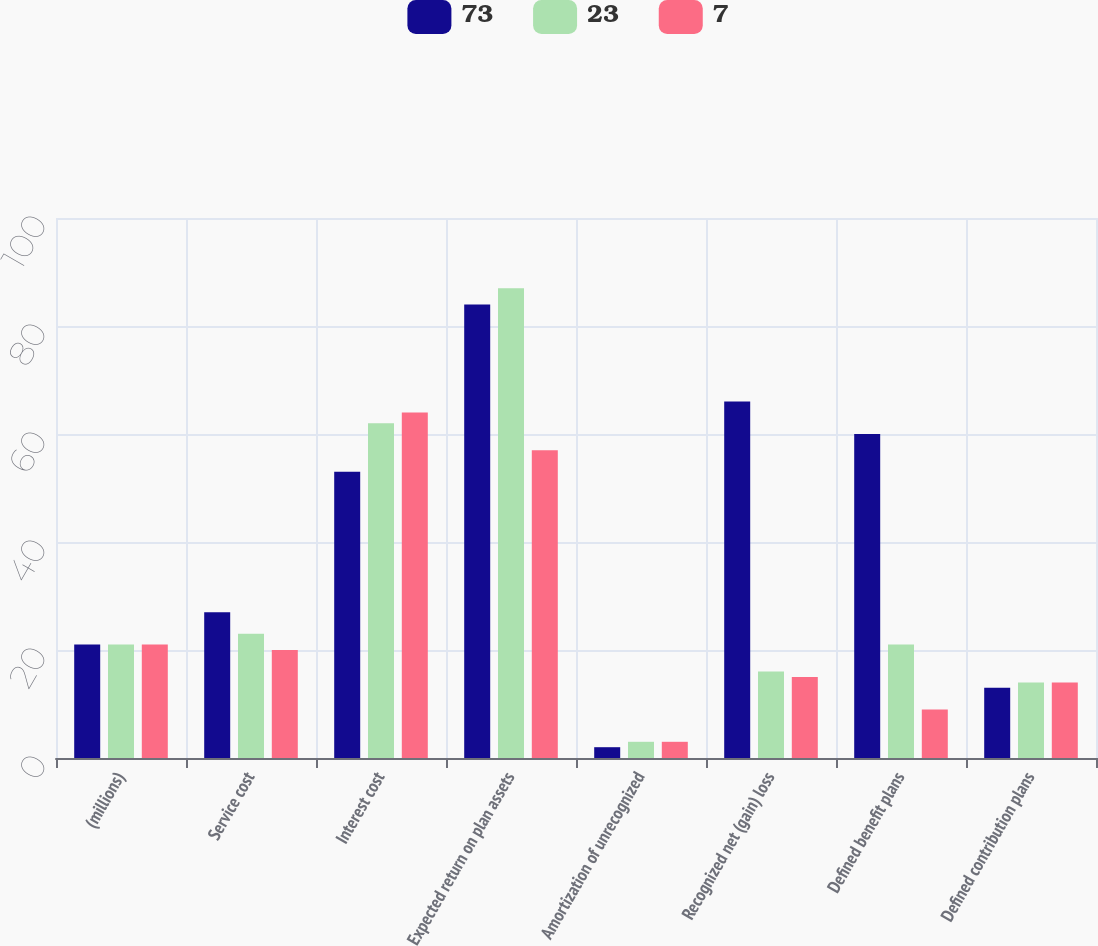Convert chart. <chart><loc_0><loc_0><loc_500><loc_500><stacked_bar_chart><ecel><fcel>(millions)<fcel>Service cost<fcel>Interest cost<fcel>Expected return on plan assets<fcel>Amortization of unrecognized<fcel>Recognized net (gain) loss<fcel>Defined benefit plans<fcel>Defined contribution plans<nl><fcel>73<fcel>21<fcel>27<fcel>53<fcel>84<fcel>2<fcel>66<fcel>60<fcel>13<nl><fcel>23<fcel>21<fcel>23<fcel>62<fcel>87<fcel>3<fcel>16<fcel>21<fcel>14<nl><fcel>7<fcel>21<fcel>20<fcel>64<fcel>57<fcel>3<fcel>15<fcel>9<fcel>14<nl></chart> 